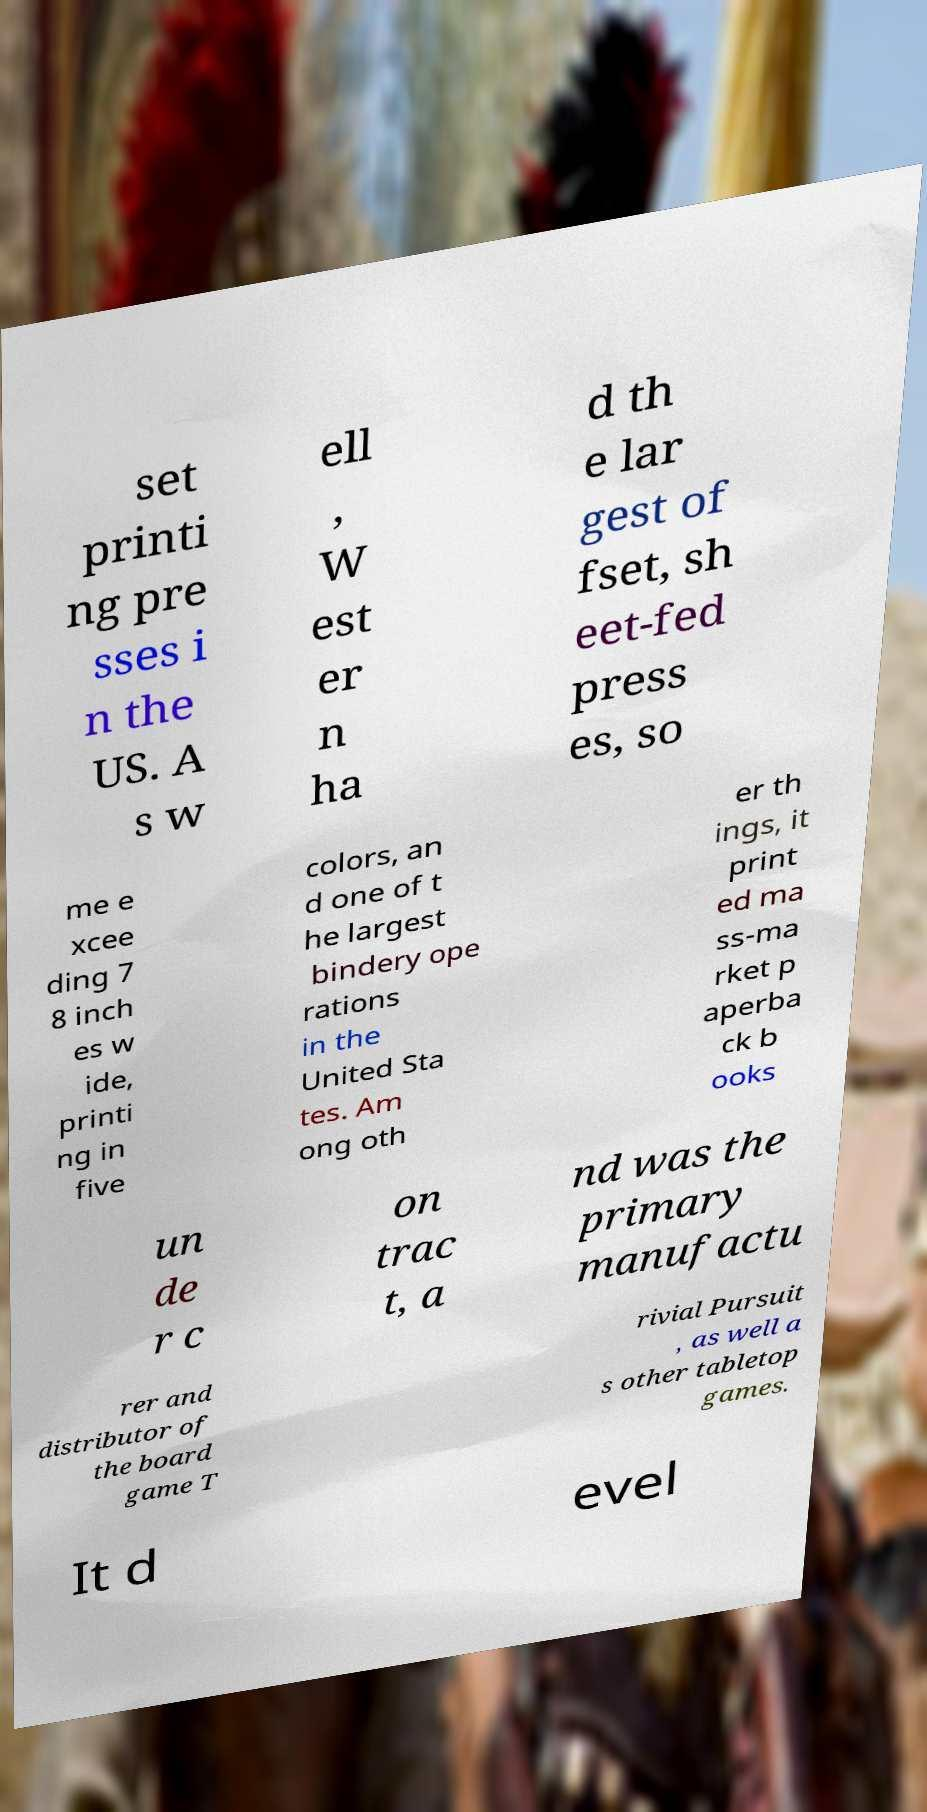There's text embedded in this image that I need extracted. Can you transcribe it verbatim? set printi ng pre sses i n the US. A s w ell , W est er n ha d th e lar gest of fset, sh eet-fed press es, so me e xcee ding 7 8 inch es w ide, printi ng in five colors, an d one of t he largest bindery ope rations in the United Sta tes. Am ong oth er th ings, it print ed ma ss-ma rket p aperba ck b ooks un de r c on trac t, a nd was the primary manufactu rer and distributor of the board game T rivial Pursuit , as well a s other tabletop games. It d evel 